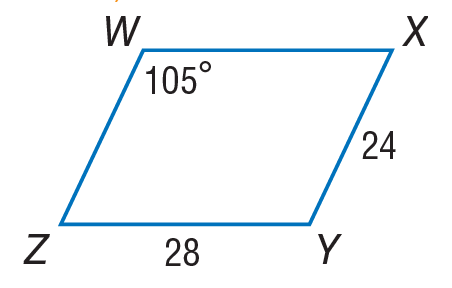Question: Use parallelogram W X Y Z to find W Z.
Choices:
A. 4
B. 24
C. 28
D. 52
Answer with the letter. Answer: B Question: Use parallelogram W X Y Z to find m \angle W Z Y.
Choices:
A. 65
B. 75
C. 105
D. 180
Answer with the letter. Answer: B 